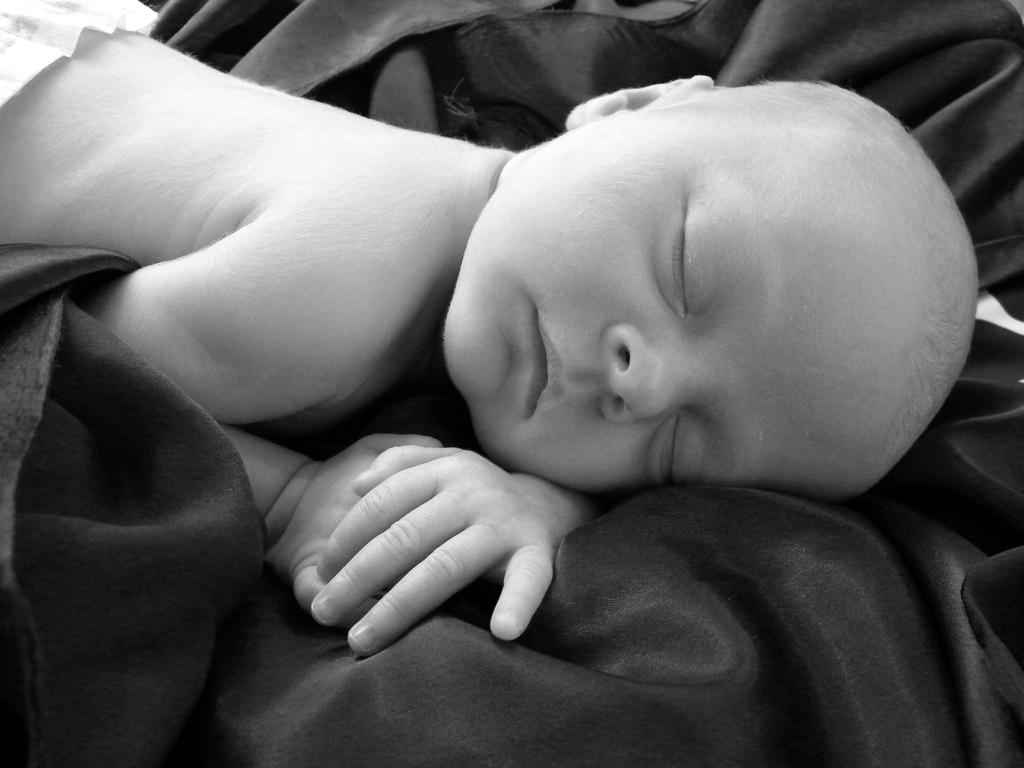What is the main subject of the image? The main subject of the image is a baby. Where is the baby located in the image? The baby is laying on a bed sheet. What is the color scheme of the image? The image is black and white. What type of plants can be seen growing around the scarecrow in the image? There is no scarecrow or plants present in the image; it features a baby laying on a bed sheet in a black and white image. 